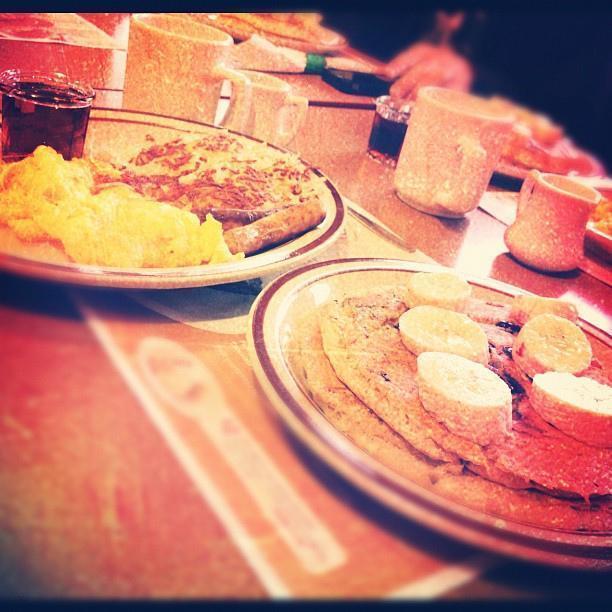How many banana slices are there?
Give a very brief answer. 6. How many cups are there?
Give a very brief answer. 5. How many pizzas are visible?
Give a very brief answer. 2. How many bananas are there?
Give a very brief answer. 3. 